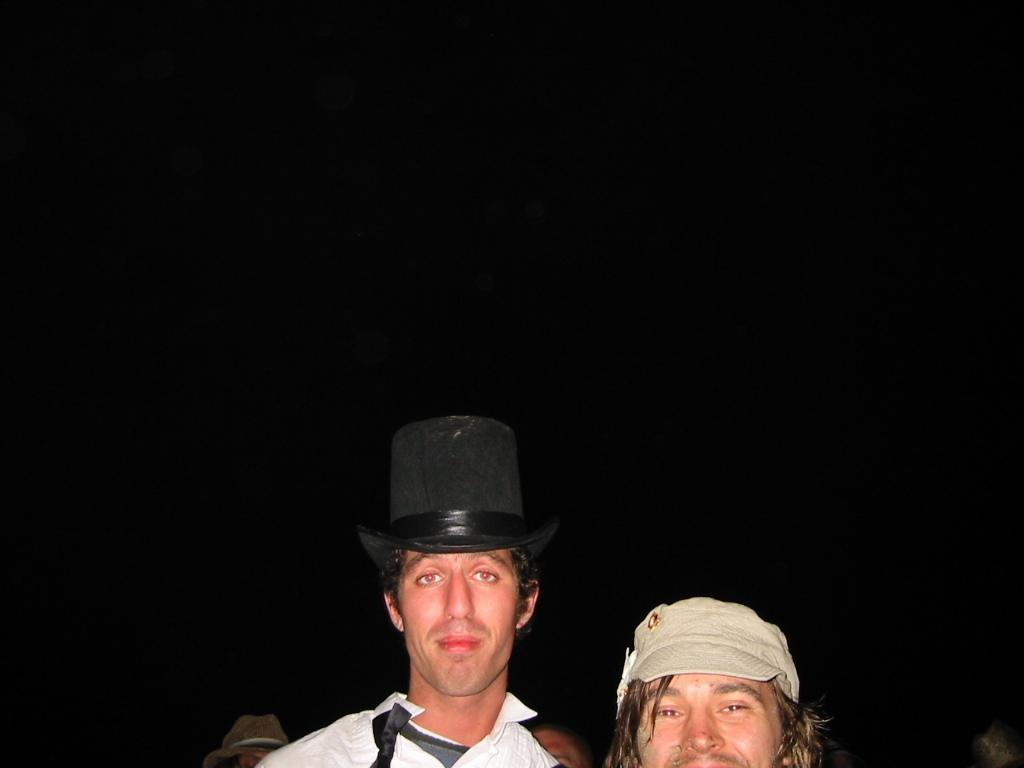In one or two sentences, can you explain what this image depicts? I think this picture is taken at night. At the bottom, there is a man wearing a white shirt and black hat. Beside him, there is another man wearing cream cap. 